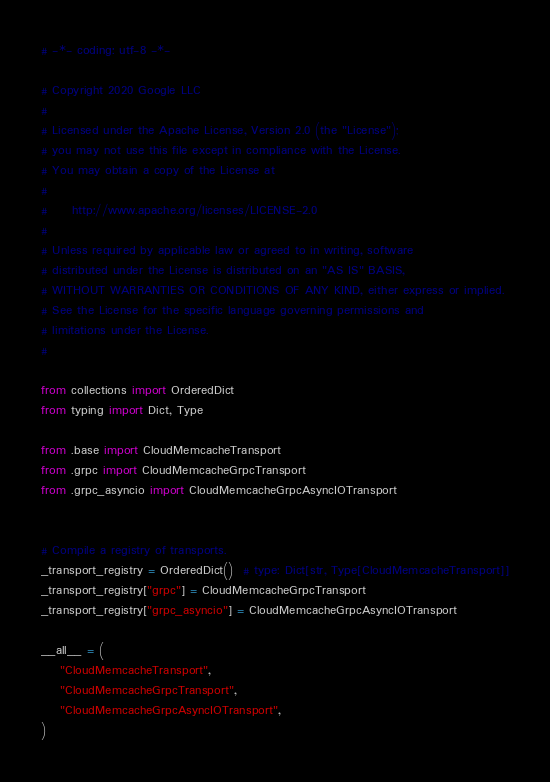<code> <loc_0><loc_0><loc_500><loc_500><_Python_># -*- coding: utf-8 -*-

# Copyright 2020 Google LLC
#
# Licensed under the Apache License, Version 2.0 (the "License");
# you may not use this file except in compliance with the License.
# You may obtain a copy of the License at
#
#     http://www.apache.org/licenses/LICENSE-2.0
#
# Unless required by applicable law or agreed to in writing, software
# distributed under the License is distributed on an "AS IS" BASIS,
# WITHOUT WARRANTIES OR CONDITIONS OF ANY KIND, either express or implied.
# See the License for the specific language governing permissions and
# limitations under the License.
#

from collections import OrderedDict
from typing import Dict, Type

from .base import CloudMemcacheTransport
from .grpc import CloudMemcacheGrpcTransport
from .grpc_asyncio import CloudMemcacheGrpcAsyncIOTransport


# Compile a registry of transports.
_transport_registry = OrderedDict()  # type: Dict[str, Type[CloudMemcacheTransport]]
_transport_registry["grpc"] = CloudMemcacheGrpcTransport
_transport_registry["grpc_asyncio"] = CloudMemcacheGrpcAsyncIOTransport

__all__ = (
    "CloudMemcacheTransport",
    "CloudMemcacheGrpcTransport",
    "CloudMemcacheGrpcAsyncIOTransport",
)
</code> 